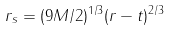<formula> <loc_0><loc_0><loc_500><loc_500>r _ { s } = ( 9 M / 2 ) ^ { 1 / 3 } ( r - t ) ^ { 2 / 3 }</formula> 